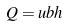<formula> <loc_0><loc_0><loc_500><loc_500>Q = u b h</formula> 